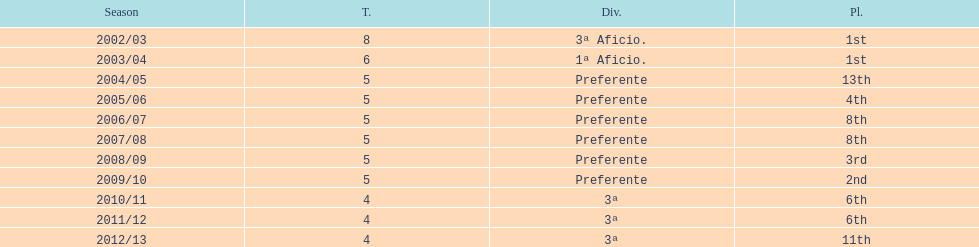Could you parse the entire table? {'header': ['Season', 'T.', 'Div.', 'Pl.'], 'rows': [['2002/03', '8', '3ª Aficio.', '1st'], ['2003/04', '6', '1ª Aficio.', '1st'], ['2004/05', '5', 'Preferente', '13th'], ['2005/06', '5', 'Preferente', '4th'], ['2006/07', '5', 'Preferente', '8th'], ['2007/08', '5', 'Preferente', '8th'], ['2008/09', '5', 'Preferente', '3rd'], ['2009/10', '5', 'Preferente', '2nd'], ['2010/11', '4', '3ª', '6th'], ['2011/12', '4', '3ª', '6th'], ['2012/13', '4', '3ª', '11th']]} How many times did internacional de madrid cf end the season at the top of their division? 2. 